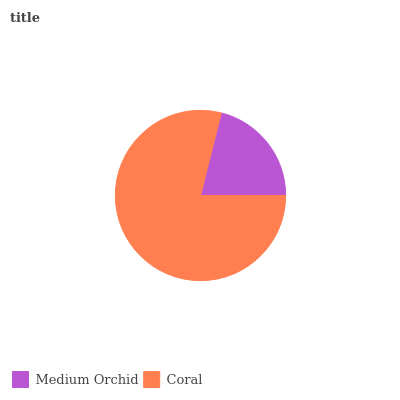Is Medium Orchid the minimum?
Answer yes or no. Yes. Is Coral the maximum?
Answer yes or no. Yes. Is Coral the minimum?
Answer yes or no. No. Is Coral greater than Medium Orchid?
Answer yes or no. Yes. Is Medium Orchid less than Coral?
Answer yes or no. Yes. Is Medium Orchid greater than Coral?
Answer yes or no. No. Is Coral less than Medium Orchid?
Answer yes or no. No. Is Coral the high median?
Answer yes or no. Yes. Is Medium Orchid the low median?
Answer yes or no. Yes. Is Medium Orchid the high median?
Answer yes or no. No. Is Coral the low median?
Answer yes or no. No. 